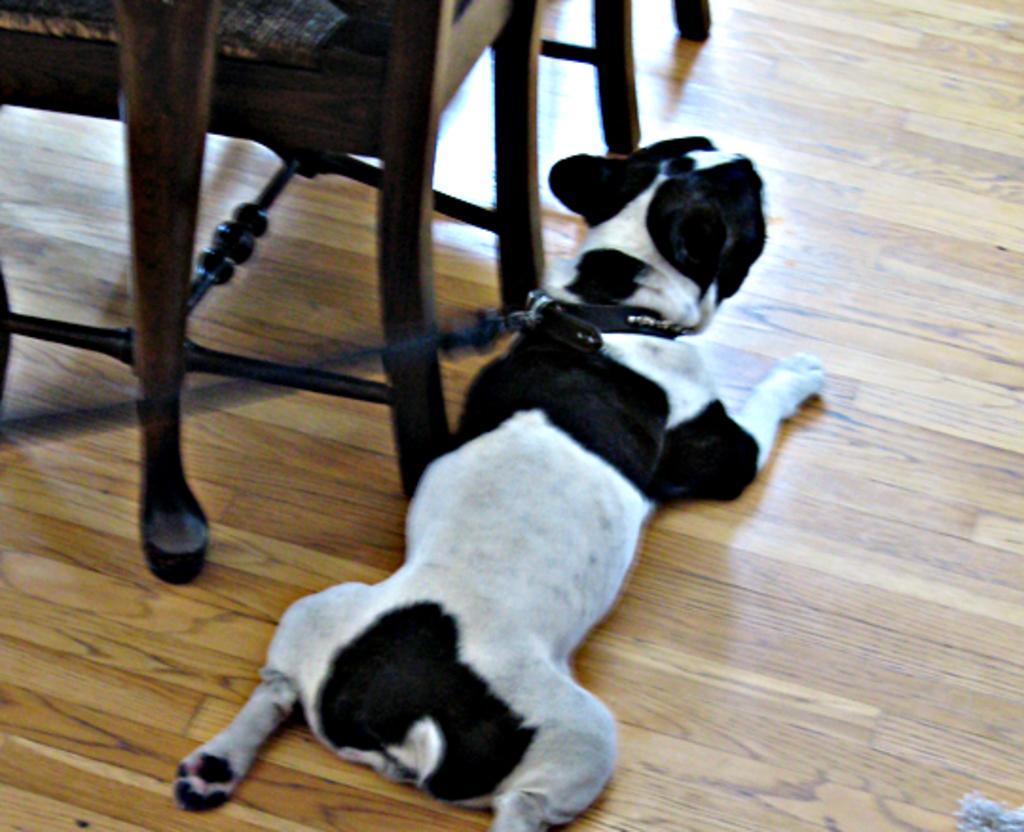Please provide a concise description of this image. A dog which is tied is lying beside a chair and table. 